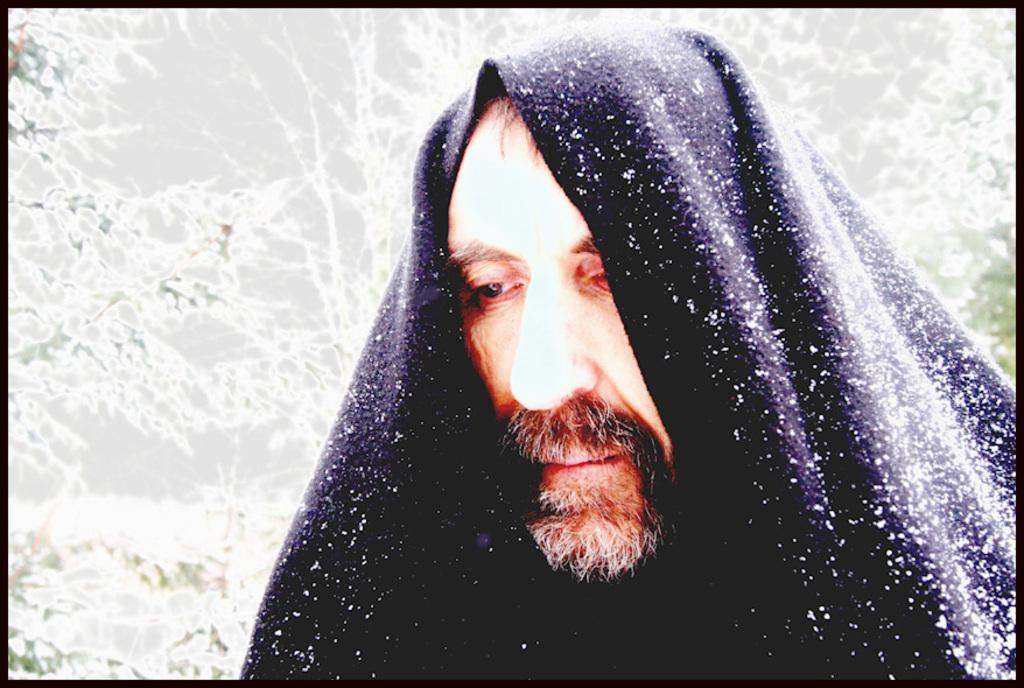What is the person in the image covered with? The person in the image is covered with cloth. What is the condition of the cloth? The cloth appears to be covered in snow. What can be seen in the background of the image? There are plants in the background of the image. What is the color of the border surrounding the image? The image has black color borders. Can you tell me how many loaves of bread are on the table in the image? There is no table or loaves of bread present in the image; it features a person covered with cloth in the snow. What type of pull is the person using to move through the snow in the image? The person is not shown pulling anything in the image; they are covered with cloth and appear to be stationary. 